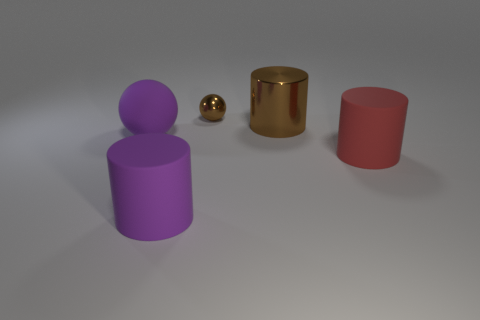Subtract all matte cylinders. How many cylinders are left? 1 Subtract 1 cylinders. How many cylinders are left? 2 Add 3 small yellow matte cylinders. How many objects exist? 8 Subtract all cylinders. How many objects are left? 2 Subtract all big brown metallic things. Subtract all brown balls. How many objects are left? 3 Add 5 brown metal cylinders. How many brown metal cylinders are left? 6 Add 1 large purple metal balls. How many large purple metal balls exist? 1 Subtract 0 gray balls. How many objects are left? 5 